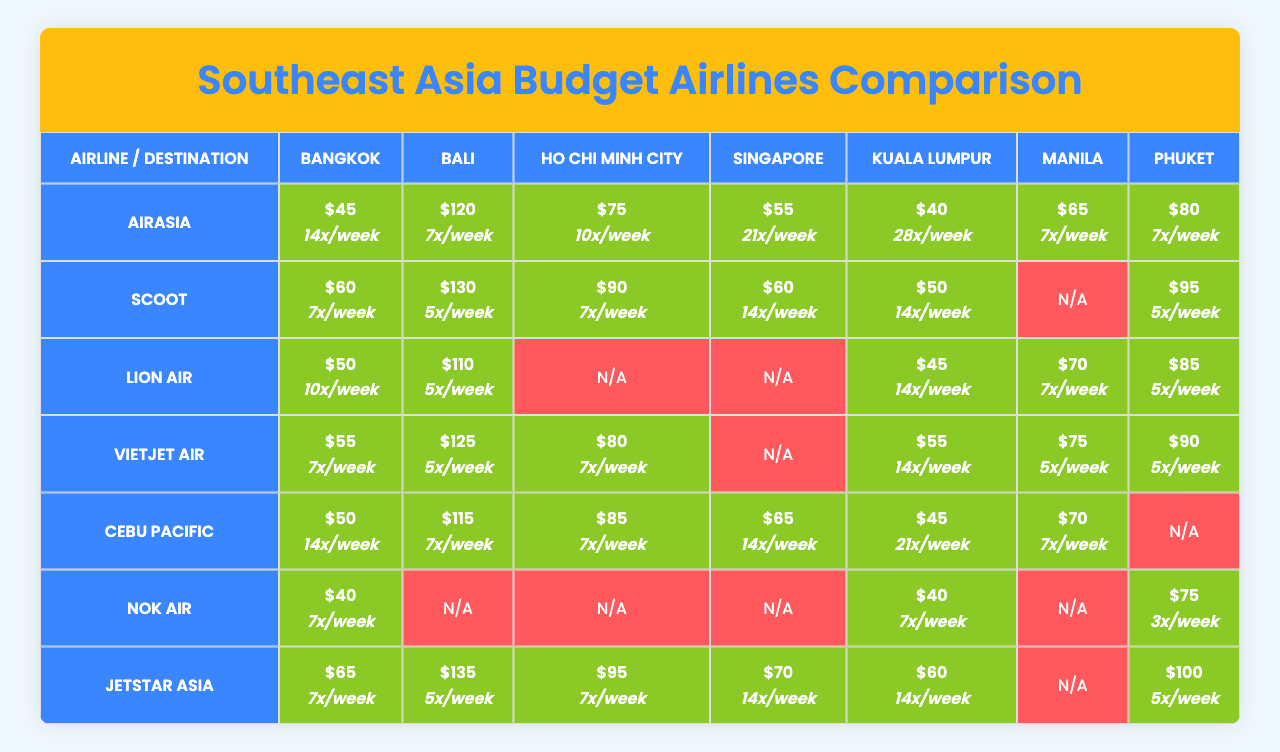What is the average fare for flights from AirAsia to Bali? From the table, AirAsia has an average fare of $120 for flights to Bali.
Answer: $120 Which airline has the highest average fare for flights to Singapore? Jetstar Asia has the highest average fare of $135 for flights to Singapore.
Answer: $135 Do all airlines offer routes to Ho Chi Minh City? No, Lion Air does not have a route to Ho Chi Minh City as indicated by "N/A" in the table.
Answer: No How many routes are available for Cebu Pacific? Cebu Pacific has routes available to 6 out of 7 destinations, with one "N/A" for Manila.
Answer: 6 routes What is the weekly flight frequency for Scoot to Kuala Lumpur? Scoot offers 14 flights per week to Kuala Lumpur, as shown in the respective cell of the table.
Answer: 14 flights/week Which airline has the most routes available among the listed airlines? Both AirAsia and Cebu Pacific have routes to 6 destinations, which is the maximum they have.
Answer: 6 routes How much cheaper is the average fare from Nok Air to Phuket compared to Jetstar Asia? Nok Air’s average fare to Phuket is $75, while Jetstar Asia’s fare is $100; therefore, Nok Air is $25 cheaper.
Answer: $25 What is the total number of weekly flights available from all airlines to Bangkok? Calculating the total weekly flights to Bangkok: 14 (AirAsia) + 7 (Scoot) + 10 (Lion Air) + 7 (VietJet Air) + 14 (Cebu Pacific) + 7 (Nok Air) + 7 (Jetstar Asia) sums to 66.
Answer: 66 flights Is there any airline that does not offer a route to Bali? Yes, VietJet Air does not offer a route to Bali as indicated by "N/A" in the table.
Answer: Yes What is the average weekly frequency of flights to Manila across all airlines? The average frequency for Manila is (7 + 0 + 7 + 5 + 7 + 0 + 0) / 7 = 2.857, rounded gives about 3 weekly flights.
Answer: 3 flights/week 